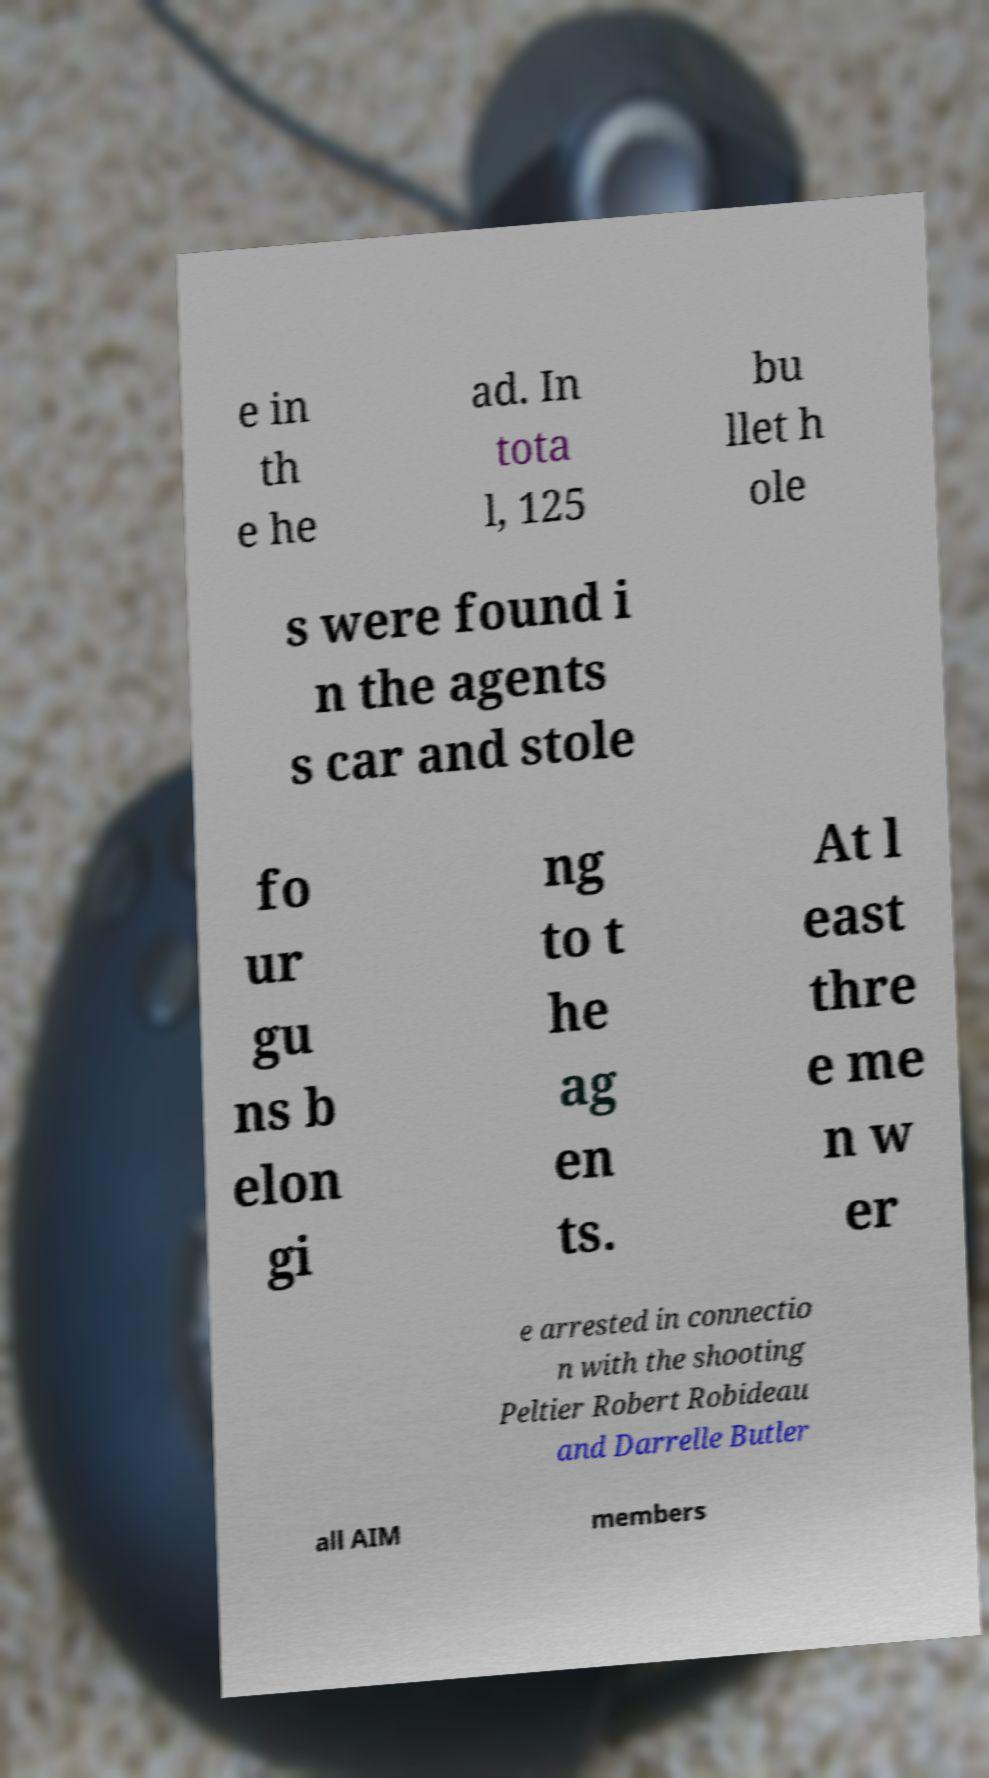Please identify and transcribe the text found in this image. e in th e he ad. In tota l, 125 bu llet h ole s were found i n the agents s car and stole fo ur gu ns b elon gi ng to t he ag en ts. At l east thre e me n w er e arrested in connectio n with the shooting Peltier Robert Robideau and Darrelle Butler all AIM members 